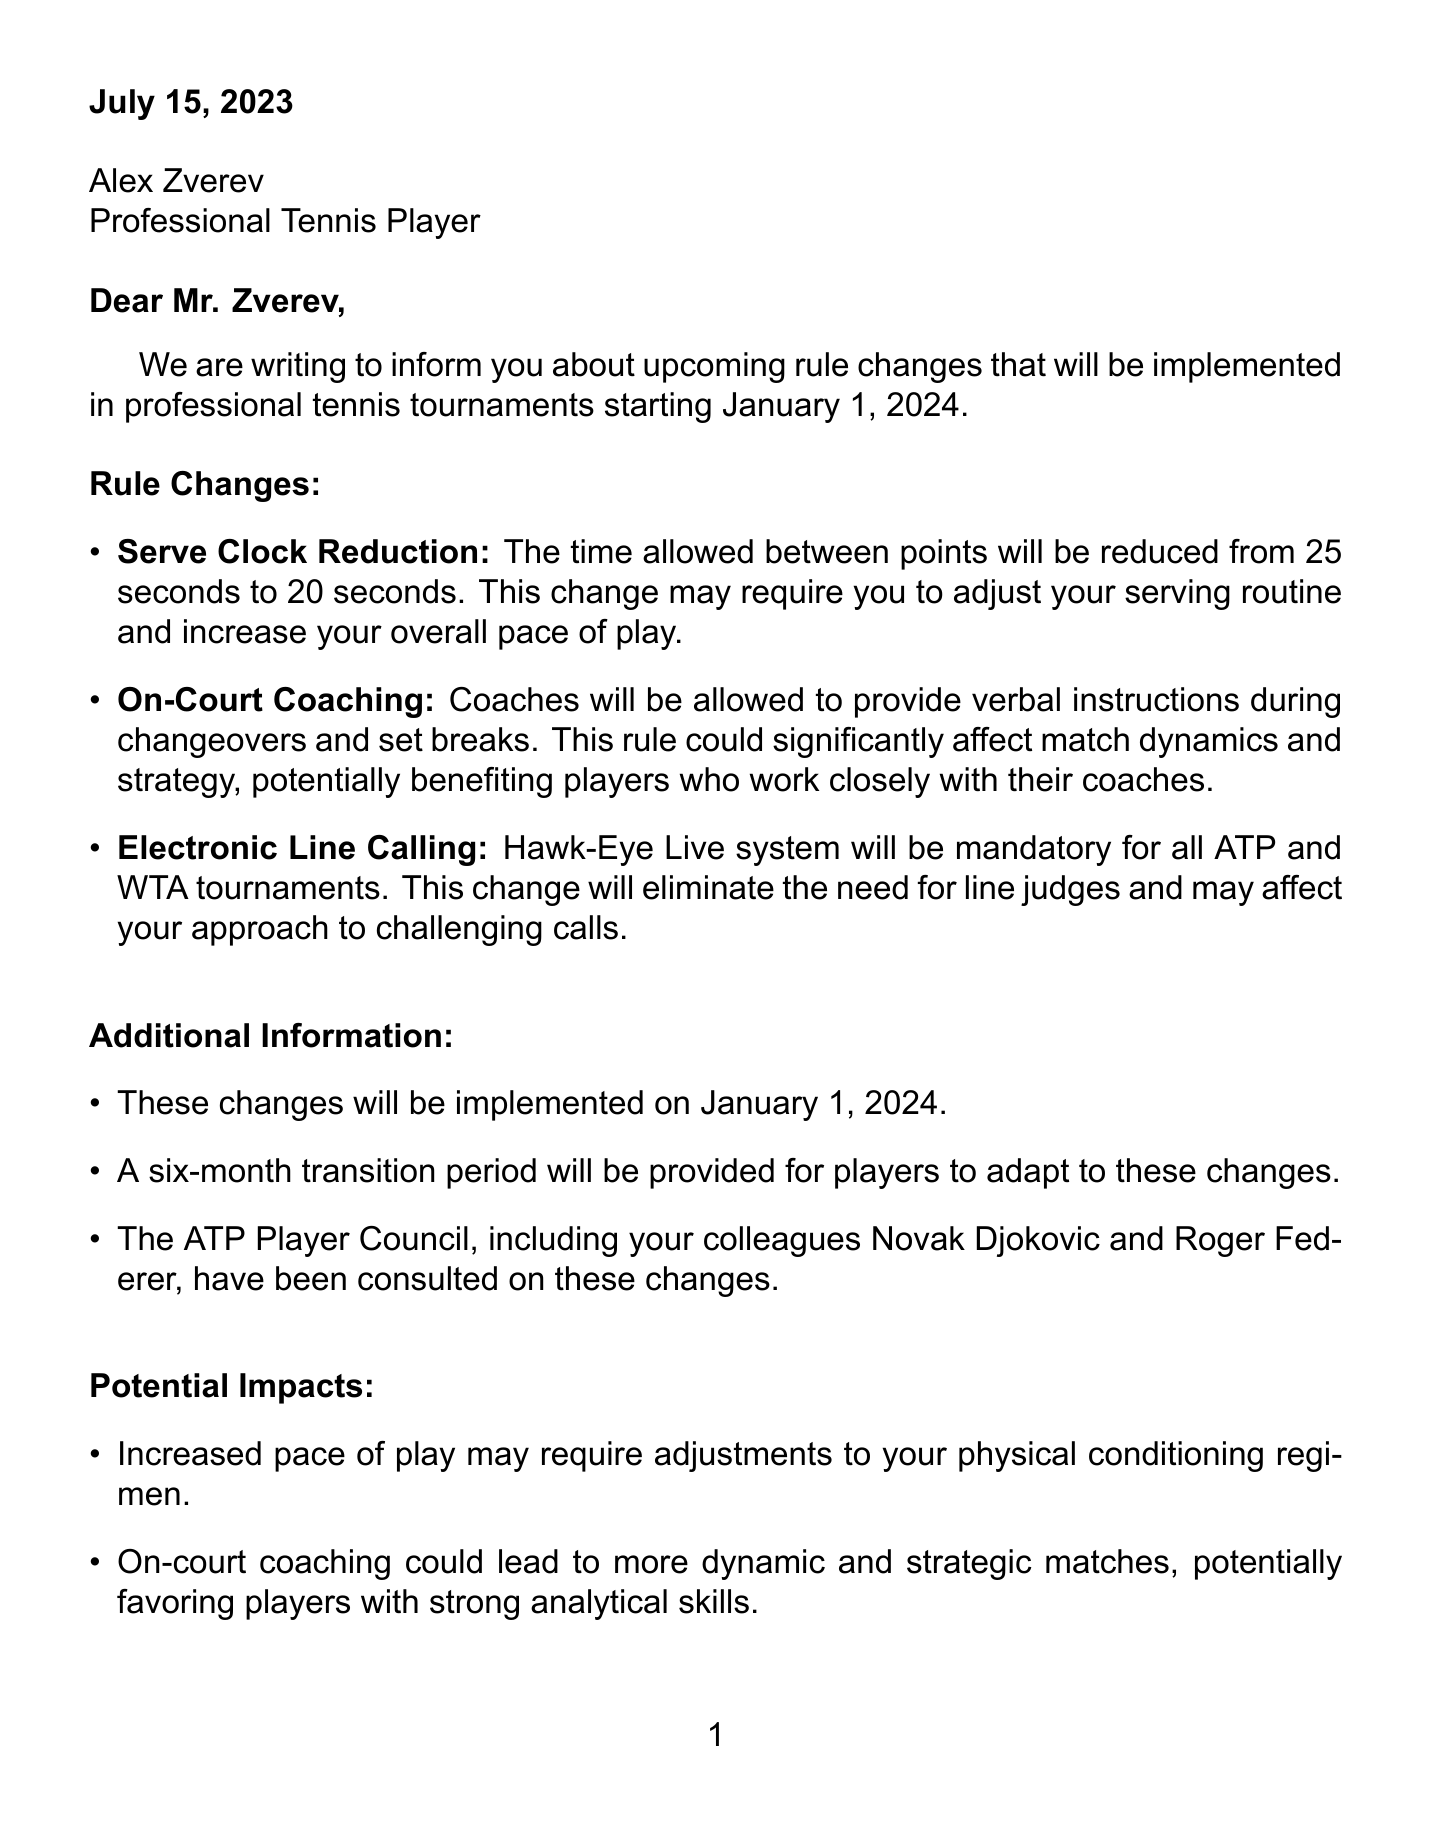what is the sender of the letter? The sender of the letter is the International Tennis Federation (ITF).
Answer: International Tennis Federation (ITF) who is the recipient of the letter? The recipient of the letter is Alex Zverev.
Answer: Alex Zverev when will the rule changes be implemented? The implementation date for the rule changes is mentioned in the document.
Answer: January 1, 2024 what is the new time allowed between points? The document specifies the new time allowed between points after the rule change.
Answer: 20 seconds what major system will be mandatory in tournaments? The document lists a specific system that will be mandatory, affecting the officiating of matches.
Answer: Hawk-Eye Live system how long is the transition period for players? The transition period mentioned in the document gives players time to adapt to the new rules.
Answer: six months what potential impact may result from the pace of play increase? The document notes a specific area that may require adjustments due to increased pace of play.
Answer: Physical conditioning regimen who is invited to attend the informational session? The letter extends an invitation which can be found in closing remarks.
Answer: Alex Zverev what is the contact email for questions? The document provides contact information for further inquiries in the closing remarks.
Answer: playerrelations@itftennis.com 